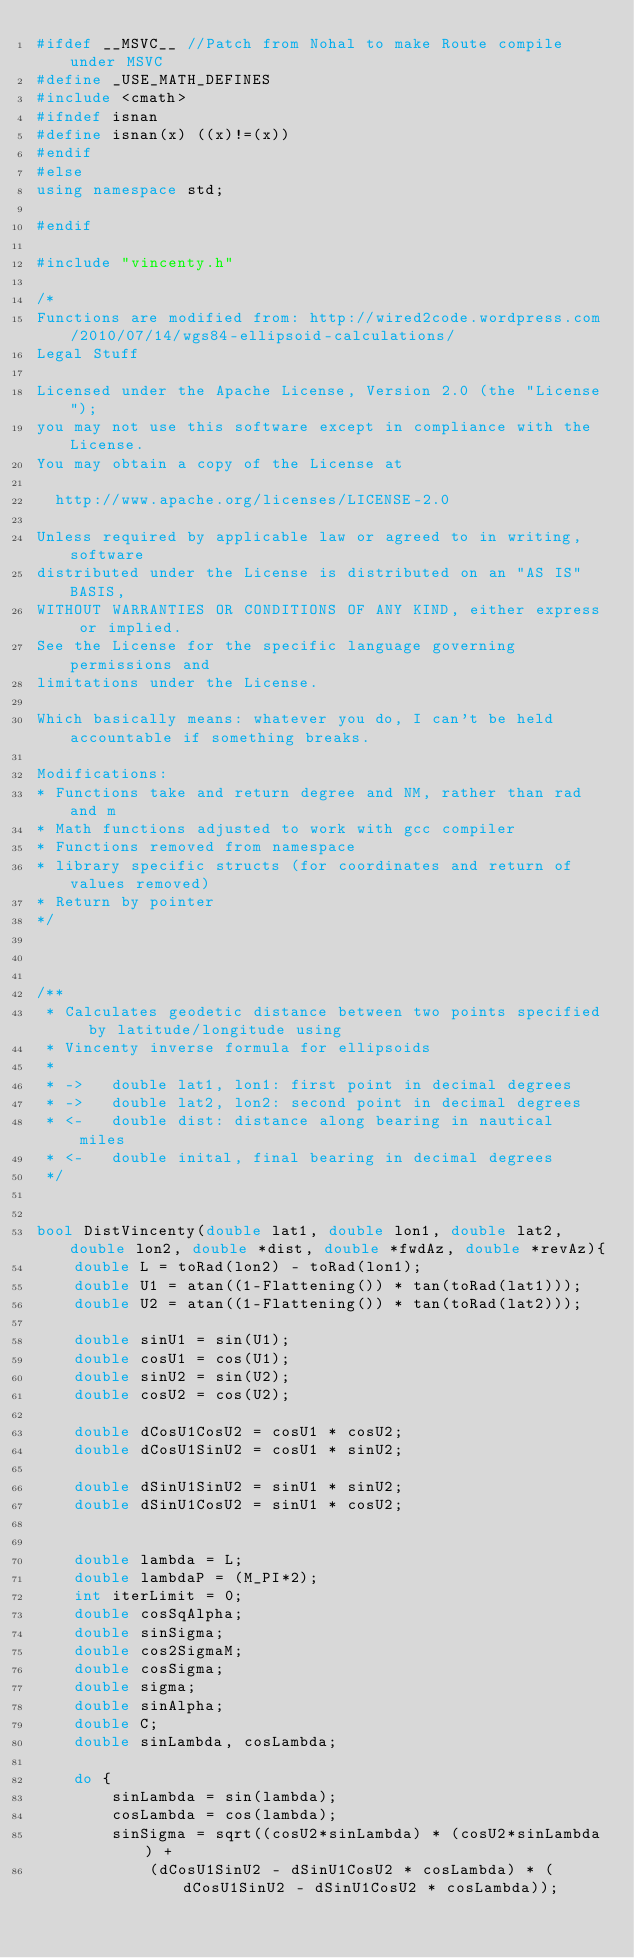Convert code to text. <code><loc_0><loc_0><loc_500><loc_500><_C++_>#ifdef __MSVC__ //Patch from Nohal to make Route compile under MSVC
#define _USE_MATH_DEFINES
#include <cmath>
#ifndef isnan
#define isnan(x) ((x)!=(x))
#endif
#else
using namespace std;

#endif

#include "vincenty.h"

/*
Functions are modified from: http://wired2code.wordpress.com/2010/07/14/wgs84-ellipsoid-calculations/
Legal Stuff

Licensed under the Apache License, Version 2.0 (the "License");
you may not use this software except in compliance with the License.
You may obtain a copy of the License at

  http://www.apache.org/licenses/LICENSE-2.0

Unless required by applicable law or agreed to in writing, software
distributed under the License is distributed on an "AS IS" BASIS,
WITHOUT WARRANTIES OR CONDITIONS OF ANY KIND, either express or implied.
See the License for the specific language governing permissions and
limitations under the License.

Which basically means: whatever you do, I can't be held accountable if something breaks.

Modifications:
* Functions take and return degree and NM, rather than rad and m
* Math functions adjusted to work with gcc compiler
* Functions removed from namespace
* library specific structs (for coordinates and return of values removed)
* Return by pointer
*/



/**
 * Calculates geodetic distance between two points specified by latitude/longitude using
 * Vincenty inverse formula for ellipsoids
 *
 * ->   double lat1, lon1: first point in decimal degrees
 * ->   double lat2, lon2: second point in decimal degrees
 * <-   double dist: distance along bearing in nautical miles
 * <-   double inital, final bearing in decimal degrees
 */


bool DistVincenty(double lat1, double lon1, double lat2, double lon2, double *dist, double *fwdAz, double *revAz){
    double L = toRad(lon2) - toRad(lon1);
    double U1 = atan((1-Flattening()) * tan(toRad(lat1)));
    double U2 = atan((1-Flattening()) * tan(toRad(lat2)));

    double sinU1 = sin(U1);
    double cosU1 = cos(U1);
    double sinU2 = sin(U2);
    double cosU2 = cos(U2);

    double dCosU1CosU2 = cosU1 * cosU2;
    double dCosU1SinU2 = cosU1 * sinU2;

    double dSinU1SinU2 = sinU1 * sinU2;
    double dSinU1CosU2 = sinU1 * cosU2;


    double lambda = L;
    double lambdaP = (M_PI*2);
    int iterLimit = 0;
    double cosSqAlpha;
    double sinSigma;
    double cos2SigmaM;
    double cosSigma;
    double sigma;
    double sinAlpha;
    double C;
    double sinLambda, cosLambda;

    do {
        sinLambda = sin(lambda);
        cosLambda = cos(lambda);
        sinSigma = sqrt((cosU2*sinLambda) * (cosU2*sinLambda) +
            (dCosU1SinU2 - dSinU1CosU2 * cosLambda) * (dCosU1SinU2 - dSinU1CosU2 * cosLambda));
</code> 